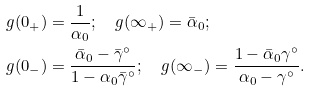<formula> <loc_0><loc_0><loc_500><loc_500>g ( 0 _ { + } ) & = \frac { 1 } { \alpha _ { 0 } } ; \quad g ( \infty _ { + } ) = \bar { \alpha } _ { 0 } ; \\ g ( 0 _ { - } ) & = \frac { \bar { \alpha } _ { 0 } - \bar { \gamma } ^ { \circ } } { 1 - \alpha _ { 0 } \bar { \gamma } ^ { \circ } } ; \quad g ( \infty _ { - } ) = \frac { 1 - \bar { \alpha } _ { 0 } \gamma ^ { \circ } } { \alpha _ { 0 } - \gamma ^ { \circ } } .</formula> 